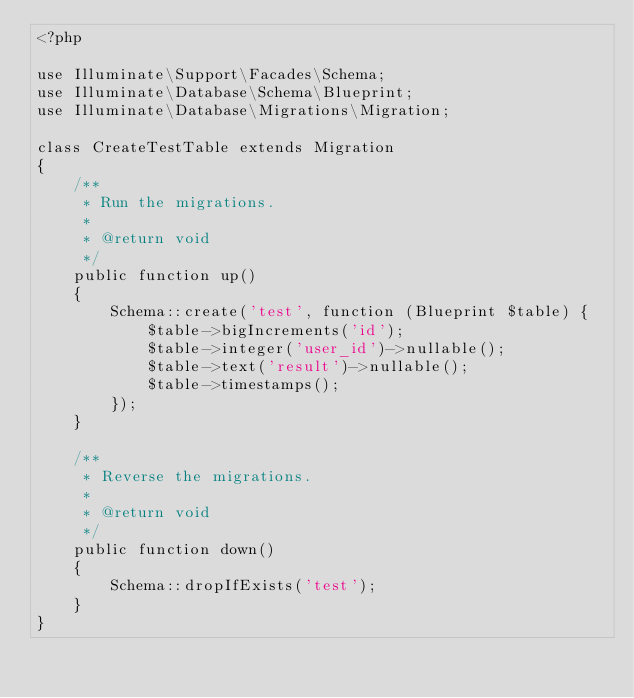Convert code to text. <code><loc_0><loc_0><loc_500><loc_500><_PHP_><?php

use Illuminate\Support\Facades\Schema;
use Illuminate\Database\Schema\Blueprint;
use Illuminate\Database\Migrations\Migration;

class CreateTestTable extends Migration
{
    /**
     * Run the migrations.
     *
     * @return void
     */
    public function up()
    {
        Schema::create('test', function (Blueprint $table) {
            $table->bigIncrements('id');
            $table->integer('user_id')->nullable();
            $table->text('result')->nullable();
            $table->timestamps();
        });
    }

    /**
     * Reverse the migrations.
     *
     * @return void
     */
    public function down()
    {
        Schema::dropIfExists('test');
    }
}
</code> 